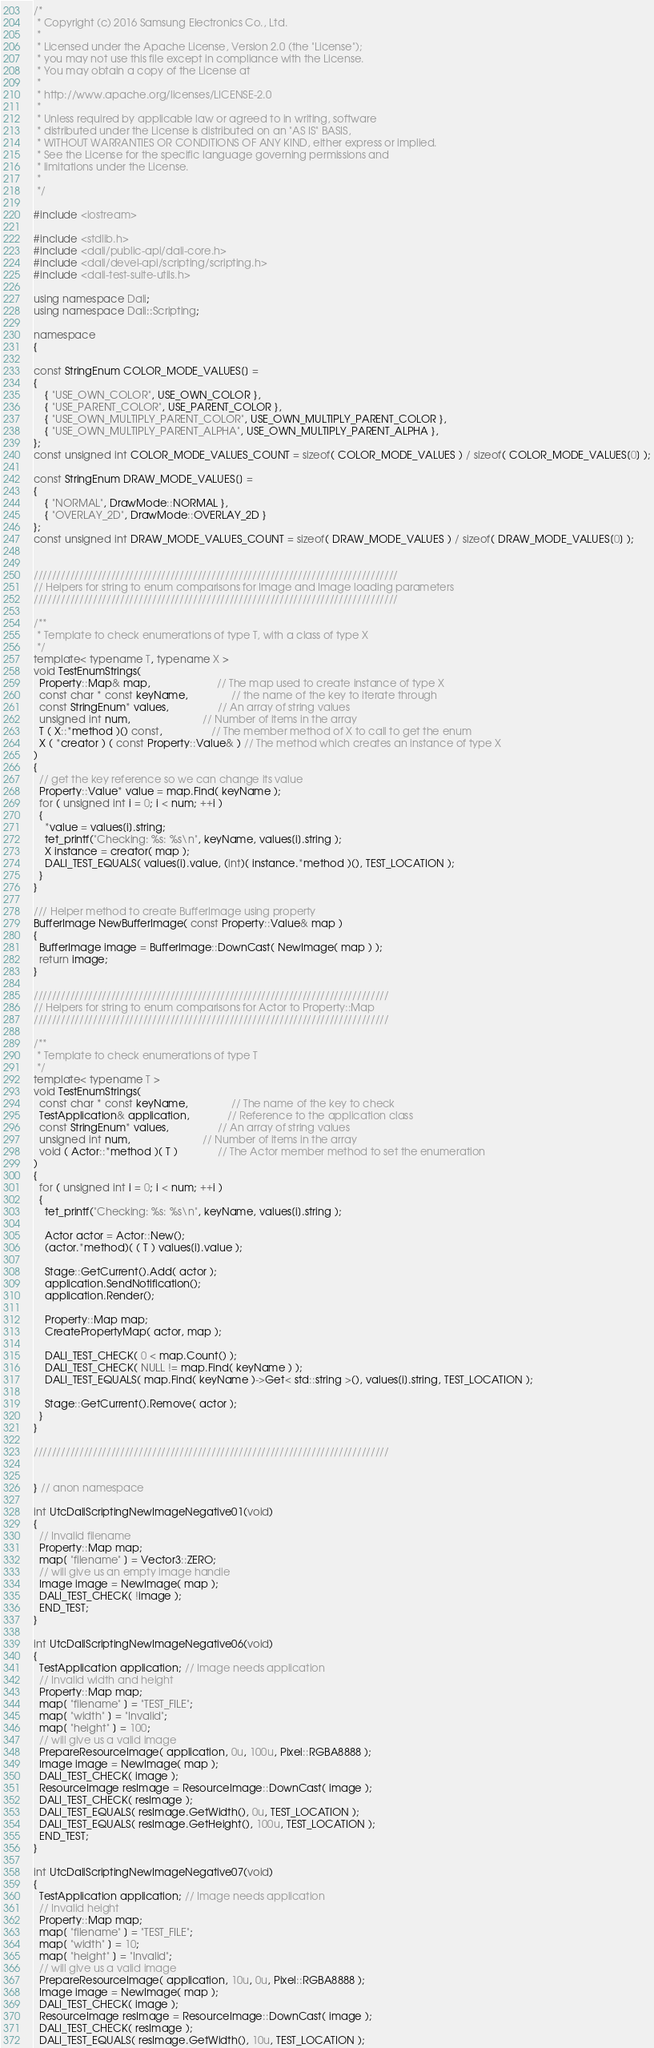Convert code to text. <code><loc_0><loc_0><loc_500><loc_500><_C++_>/*
 * Copyright (c) 2016 Samsung Electronics Co., Ltd.
 *
 * Licensed under the Apache License, Version 2.0 (the "License");
 * you may not use this file except in compliance with the License.
 * You may obtain a copy of the License at
 *
 * http://www.apache.org/licenses/LICENSE-2.0
 *
 * Unless required by applicable law or agreed to in writing, software
 * distributed under the License is distributed on an "AS IS" BASIS,
 * WITHOUT WARRANTIES OR CONDITIONS OF ANY KIND, either express or implied.
 * See the License for the specific language governing permissions and
 * limitations under the License.
 *
 */

#include <iostream>

#include <stdlib.h>
#include <dali/public-api/dali-core.h>
#include <dali/devel-api/scripting/scripting.h>
#include <dali-test-suite-utils.h>

using namespace Dali;
using namespace Dali::Scripting;

namespace
{

const StringEnum COLOR_MODE_VALUES[] =
{
    { "USE_OWN_COLOR", USE_OWN_COLOR },
    { "USE_PARENT_COLOR", USE_PARENT_COLOR },
    { "USE_OWN_MULTIPLY_PARENT_COLOR", USE_OWN_MULTIPLY_PARENT_COLOR },
    { "USE_OWN_MULTIPLY_PARENT_ALPHA", USE_OWN_MULTIPLY_PARENT_ALPHA },
};
const unsigned int COLOR_MODE_VALUES_COUNT = sizeof( COLOR_MODE_VALUES ) / sizeof( COLOR_MODE_VALUES[0] );

const StringEnum DRAW_MODE_VALUES[] =
{
    { "NORMAL", DrawMode::NORMAL },
    { "OVERLAY_2D", DrawMode::OVERLAY_2D }
};
const unsigned int DRAW_MODE_VALUES_COUNT = sizeof( DRAW_MODE_VALUES ) / sizeof( DRAW_MODE_VALUES[0] );


////////////////////////////////////////////////////////////////////////////////
// Helpers for string to enum comparisons for Image and Image loading parameters
////////////////////////////////////////////////////////////////////////////////

/**
 * Template to check enumerations of type T, with a class of type X
 */
template< typename T, typename X >
void TestEnumStrings(
  Property::Map& map,                       // The map used to create instance of type X
  const char * const keyName,               // the name of the key to iterate through
  const StringEnum* values,                 // An array of string values
  unsigned int num,                         // Number of items in the array
  T ( X::*method )() const,                 // The member method of X to call to get the enum
  X ( *creator ) ( const Property::Value& ) // The method which creates an instance of type X
)
{
  // get the key reference so we can change its value
  Property::Value* value = map.Find( keyName );
  for ( unsigned int i = 0; i < num; ++i )
  {
    *value = values[i].string;
    tet_printf("Checking: %s: %s\n", keyName, values[i].string );
    X instance = creator( map );
    DALI_TEST_EQUALS( values[i].value, (int)( instance.*method )(), TEST_LOCATION );
  }
}

/// Helper method to create BufferImage using property
BufferImage NewBufferImage( const Property::Value& map )
{
  BufferImage image = BufferImage::DownCast( NewImage( map ) );
  return image;
}

//////////////////////////////////////////////////////////////////////////////
// Helpers for string to enum comparisons for Actor to Property::Map
//////////////////////////////////////////////////////////////////////////////

/**
 * Template to check enumerations of type T
 */
template< typename T >
void TestEnumStrings(
  const char * const keyName,               // The name of the key to check
  TestApplication& application,             // Reference to the application class
  const StringEnum* values,                 // An array of string values
  unsigned int num,                         // Number of items in the array
  void ( Actor::*method )( T )              // The Actor member method to set the enumeration
)
{
  for ( unsigned int i = 0; i < num; ++i )
  {
    tet_printf("Checking: %s: %s\n", keyName, values[i].string );

    Actor actor = Actor::New();
    (actor.*method)( ( T ) values[i].value );

    Stage::GetCurrent().Add( actor );
    application.SendNotification();
    application.Render();

    Property::Map map;
    CreatePropertyMap( actor, map );

    DALI_TEST_CHECK( 0 < map.Count() );
    DALI_TEST_CHECK( NULL != map.Find( keyName ) );
    DALI_TEST_EQUALS( map.Find( keyName )->Get< std::string >(), values[i].string, TEST_LOCATION );

    Stage::GetCurrent().Remove( actor );
  }
}

//////////////////////////////////////////////////////////////////////////////


} // anon namespace

int UtcDaliScriptingNewImageNegative01(void)
{
  // Invalid filename
  Property::Map map;
  map[ "filename" ] = Vector3::ZERO;
  // will give us an empty image handle
  Image image = NewImage( map );
  DALI_TEST_CHECK( !image );
  END_TEST;
}

int UtcDaliScriptingNewImageNegative06(void)
{
  TestApplication application; // Image needs application
  // Invalid width and height
  Property::Map map;
  map[ "filename" ] = "TEST_FILE";
  map[ "width" ] = "Invalid";
  map[ "height" ] = 100;
  // will give us a valid image
  PrepareResourceImage( application, 0u, 100u, Pixel::RGBA8888 );
  Image image = NewImage( map );
  DALI_TEST_CHECK( image );
  ResourceImage resImage = ResourceImage::DownCast( image );
  DALI_TEST_CHECK( resImage );
  DALI_TEST_EQUALS( resImage.GetWidth(), 0u, TEST_LOCATION );
  DALI_TEST_EQUALS( resImage.GetHeight(), 100u, TEST_LOCATION );
  END_TEST;
}

int UtcDaliScriptingNewImageNegative07(void)
{
  TestApplication application; // Image needs application
  // Invalid height
  Property::Map map;
  map[ "filename" ] = "TEST_FILE";
  map[ "width" ] = 10;
  map[ "height" ] = "Invalid";
  // will give us a valid image
  PrepareResourceImage( application, 10u, 0u, Pixel::RGBA8888 );
  Image image = NewImage( map );
  DALI_TEST_CHECK( image );
  ResourceImage resImage = ResourceImage::DownCast( image );
  DALI_TEST_CHECK( resImage );
  DALI_TEST_EQUALS( resImage.GetWidth(), 10u, TEST_LOCATION );</code> 